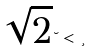<formula> <loc_0><loc_0><loc_500><loc_500>\sqrt { 2 } \lambda < \xi</formula> 